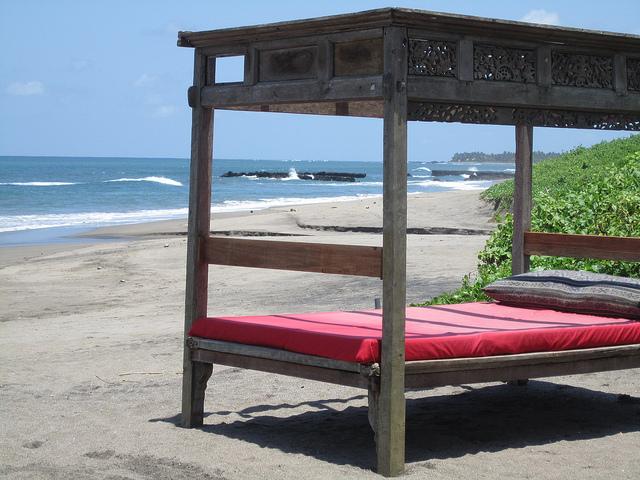What is on the beach?
Short answer required. Bed. What kind of bed is this?
Be succinct. Bunk. Would the sand feel hot to bare feet?
Quick response, please. Yes. 